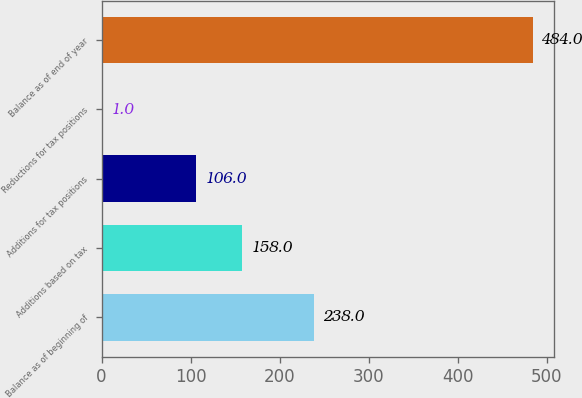Convert chart to OTSL. <chart><loc_0><loc_0><loc_500><loc_500><bar_chart><fcel>Balance as of beginning of<fcel>Additions based on tax<fcel>Additions for tax positions<fcel>Reductions for tax positions<fcel>Balance as of end of year<nl><fcel>238<fcel>158<fcel>106<fcel>1<fcel>484<nl></chart> 